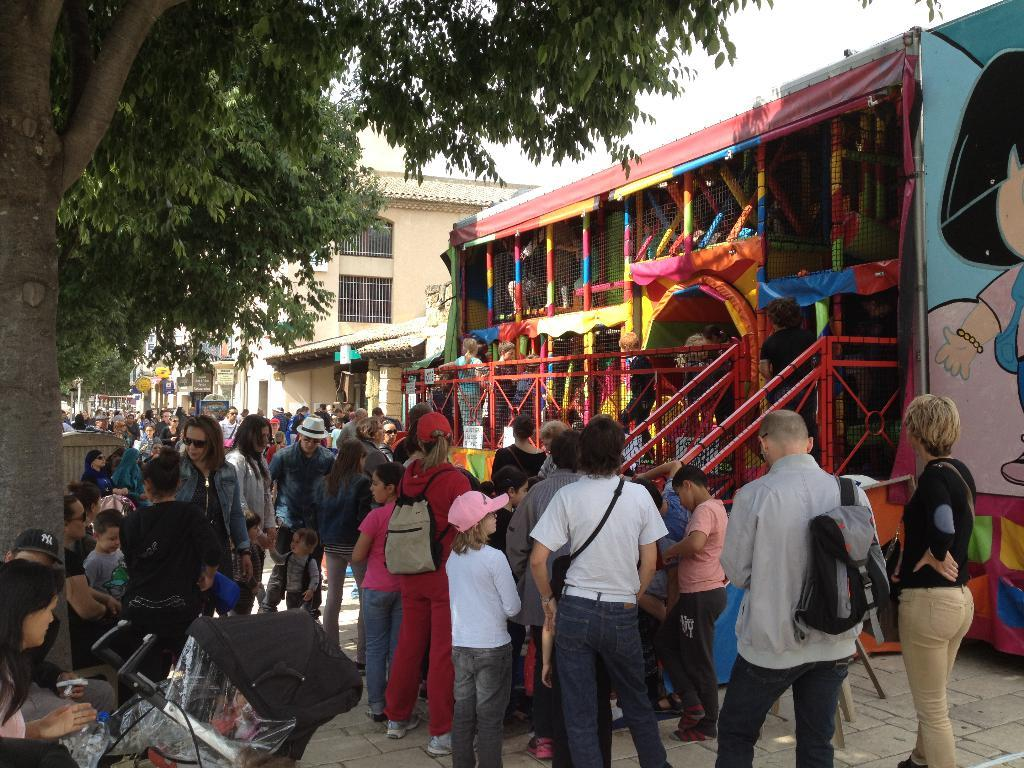What type of structures can be seen in the image? There are buildings in the image. What area is designated for recreational activities in the image? There is a play zone in the image. What safety feature is present in the image? There is railing in the image. What type of vegetation is visible in the image? There are trees in the image. Who or what is present in the image? There are people in the image. What type of surface is visible in the image? There is a path in the image. What part of the natural environment is visible in the image? The sky is visible in the image. What type of waste can be seen in the image? There is no waste present in the image. What time of day is depicted in the image? The time of day cannot be determined from the image. 